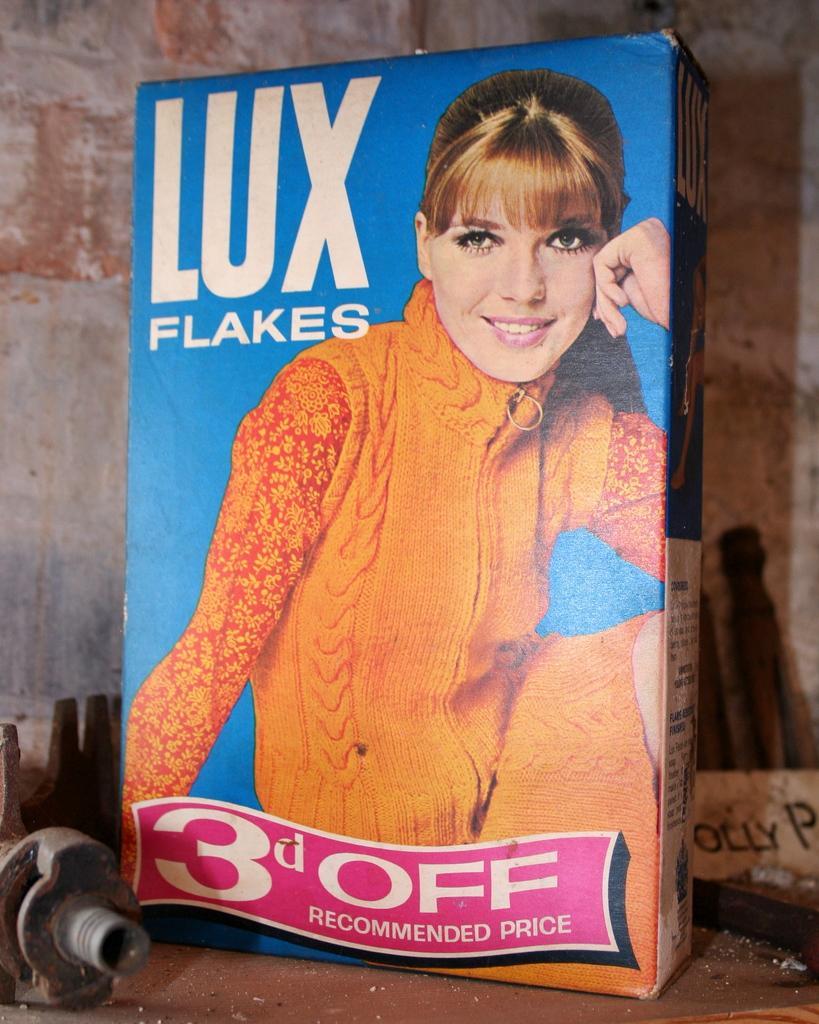In one or two sentences, can you explain what this image depicts? In this picture I can see there is a box and it has a picture of a woman sitting, wearing a sweater and smiling. There is something written on the box and there is a wall in the backdrop. 